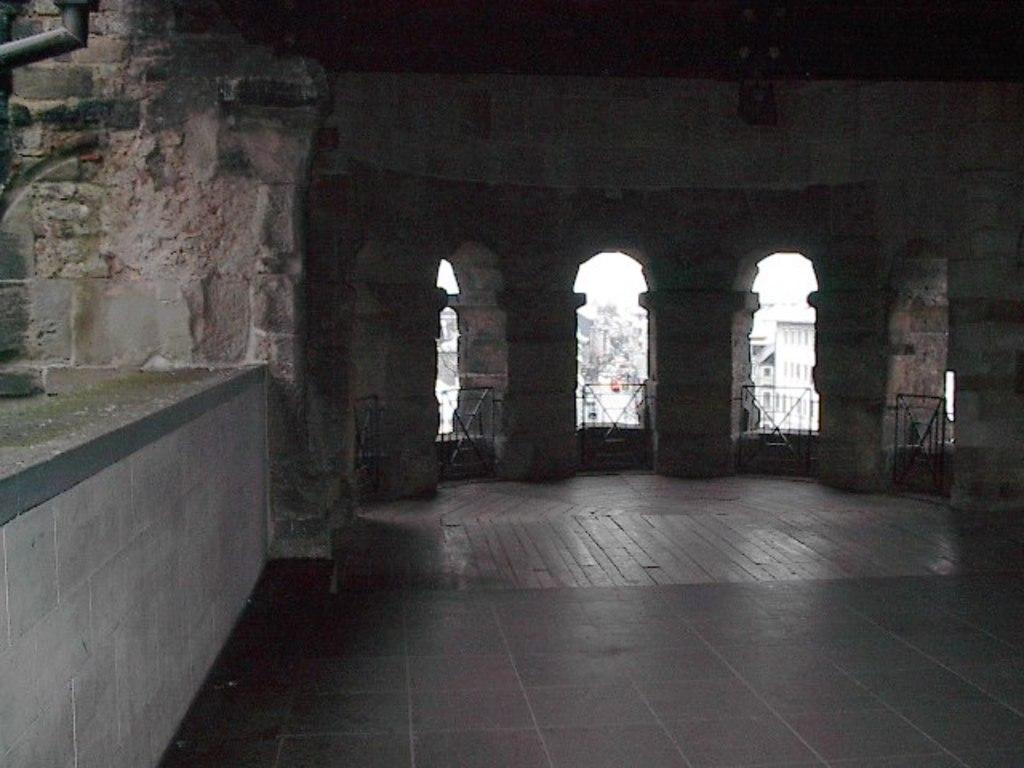In one or two sentences, can you explain what this image depicts? This might be clicked inside a building. This looks like an old building. 